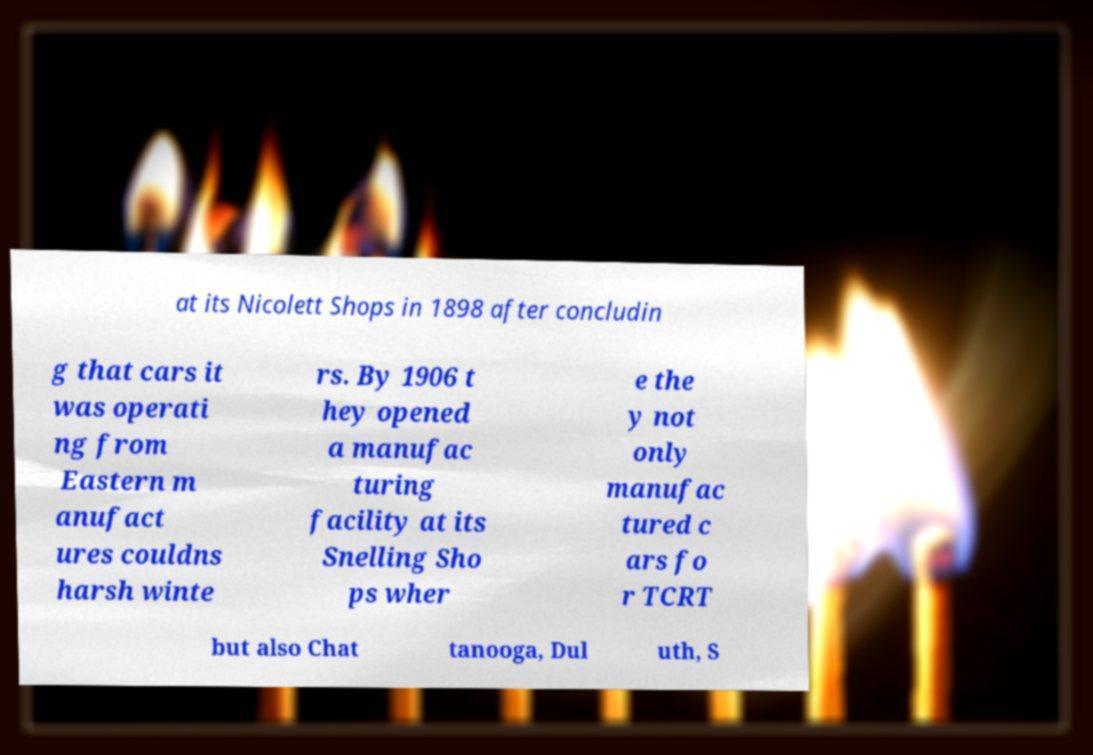Please read and relay the text visible in this image. What does it say? at its Nicolett Shops in 1898 after concludin g that cars it was operati ng from Eastern m anufact ures couldns harsh winte rs. By 1906 t hey opened a manufac turing facility at its Snelling Sho ps wher e the y not only manufac tured c ars fo r TCRT but also Chat tanooga, Dul uth, S 